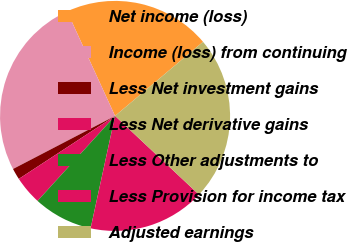<chart> <loc_0><loc_0><loc_500><loc_500><pie_chart><fcel>Net income (loss)<fcel>Income (loss) from continuing<fcel>Less Net investment gains<fcel>Less Net derivative gains<fcel>Less Other adjustments to<fcel>Less Provision for income tax<fcel>Adjusted earnings<nl><fcel>20.71%<fcel>25.79%<fcel>1.59%<fcel>4.01%<fcel>8.36%<fcel>16.42%<fcel>23.13%<nl></chart> 